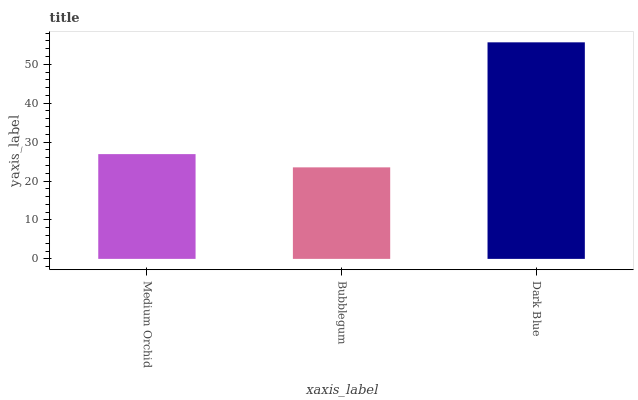Is Bubblegum the minimum?
Answer yes or no. Yes. Is Dark Blue the maximum?
Answer yes or no. Yes. Is Dark Blue the minimum?
Answer yes or no. No. Is Bubblegum the maximum?
Answer yes or no. No. Is Dark Blue greater than Bubblegum?
Answer yes or no. Yes. Is Bubblegum less than Dark Blue?
Answer yes or no. Yes. Is Bubblegum greater than Dark Blue?
Answer yes or no. No. Is Dark Blue less than Bubblegum?
Answer yes or no. No. Is Medium Orchid the high median?
Answer yes or no. Yes. Is Medium Orchid the low median?
Answer yes or no. Yes. Is Bubblegum the high median?
Answer yes or no. No. Is Bubblegum the low median?
Answer yes or no. No. 